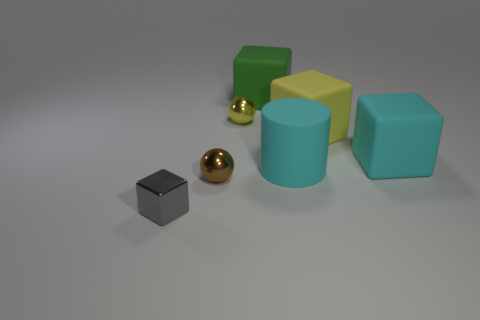Did the creator of this scene have a specific theme or message in mind? While we can't determine the creator's intent without further information, the scene's orderly arrangement of geometric shapes and contrasting materials could represent themes of organization, diversity, or balance. 